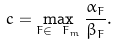Convert formula to latex. <formula><loc_0><loc_0><loc_500><loc_500>c = \max _ { F \in \ F _ { m } } \frac { \alpha _ { F } } { \beta _ { F } } .</formula> 